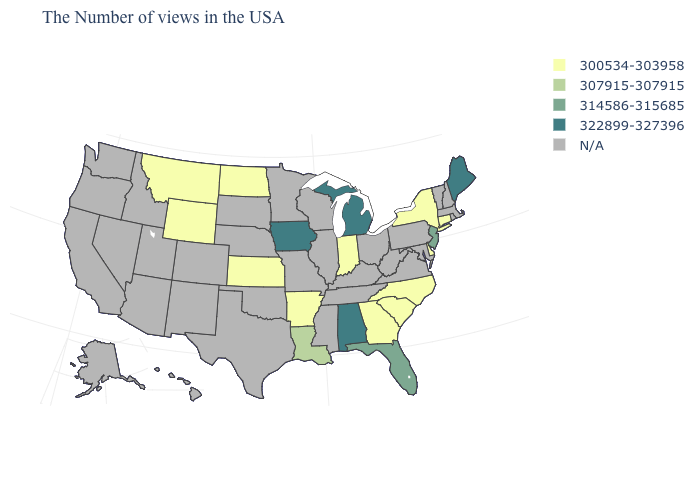What is the lowest value in the USA?
Quick response, please. 300534-303958. What is the lowest value in the USA?
Give a very brief answer. 300534-303958. What is the value of Arkansas?
Be succinct. 300534-303958. Name the states that have a value in the range 307915-307915?
Quick response, please. Louisiana. What is the value of New Jersey?
Quick response, please. 314586-315685. What is the value of South Dakota?
Keep it brief. N/A. What is the value of Hawaii?
Give a very brief answer. N/A. What is the highest value in states that border Utah?
Write a very short answer. 300534-303958. Does Iowa have the highest value in the MidWest?
Short answer required. Yes. What is the lowest value in the South?
Short answer required. 300534-303958. What is the value of South Dakota?
Keep it brief. N/A. Name the states that have a value in the range 314586-315685?
Short answer required. New Jersey, Florida. What is the value of West Virginia?
Give a very brief answer. N/A. 